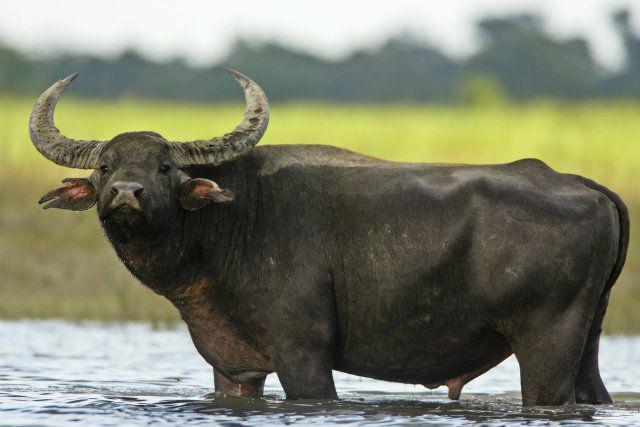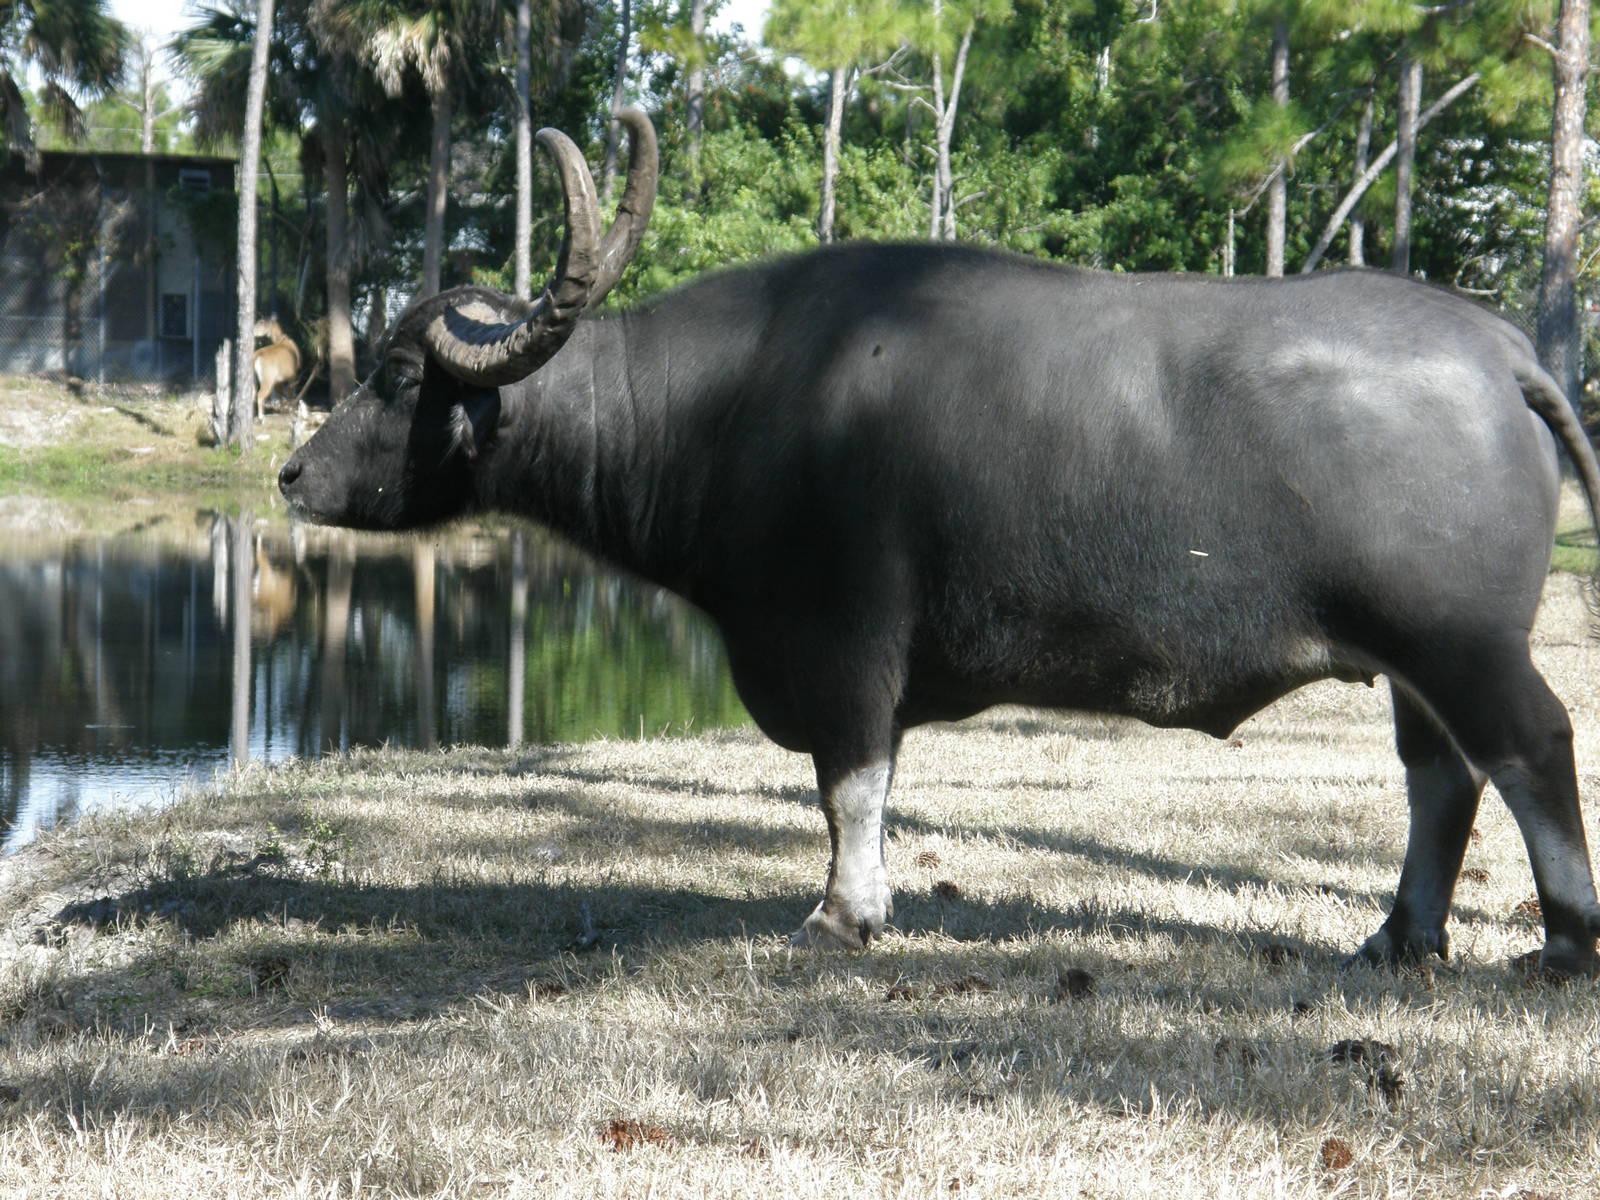The first image is the image on the left, the second image is the image on the right. Examine the images to the left and right. Is the description "A water buffalo is standing in water." accurate? Answer yes or no. Yes. The first image is the image on the left, the second image is the image on the right. For the images shown, is this caption "An image shows a water buffalo standing in water." true? Answer yes or no. Yes. 